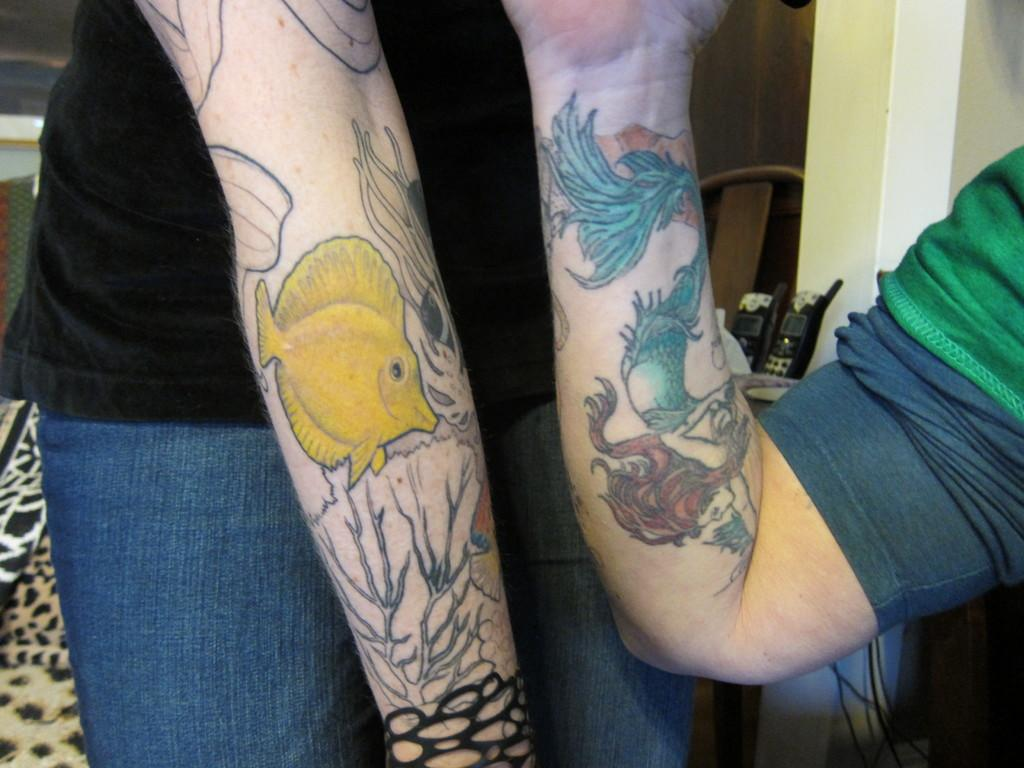How many people are in the image? There are two people in the image. What are the people doing in the image? The people are on their hands in the image. What can be seen on the people's bodies in the image? There are tattoos visible on the people. What type of card is being used to shovel snow in the image? There is no card or snow present in the image; it features two people on their hands with visible tattoos. 